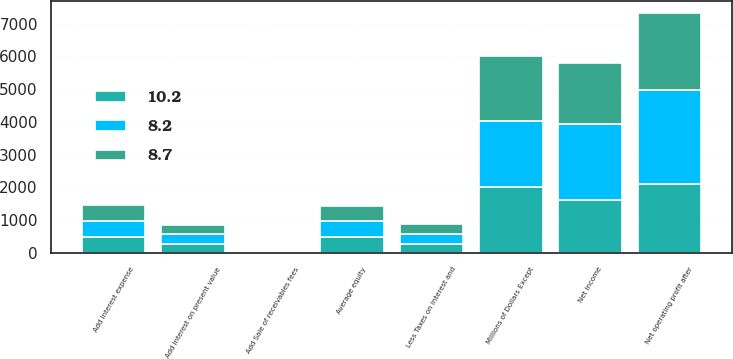Convert chart. <chart><loc_0><loc_0><loc_500><loc_500><stacked_bar_chart><ecel><fcel>Millions of Dollars Except<fcel>Net income<fcel>Add Interest expense<fcel>Add Sale of receivables fees<fcel>Add Interest on present value<fcel>Less Taxes on interest and<fcel>Net operating profit after<fcel>Average equity<nl><fcel>8.2<fcel>2008<fcel>2338<fcel>511<fcel>23<fcel>299<fcel>301<fcel>2870<fcel>482<nl><fcel>8.7<fcel>2007<fcel>1855<fcel>482<fcel>35<fcel>292<fcel>310<fcel>2354<fcel>482<nl><fcel>10.2<fcel>2006<fcel>1606<fcel>477<fcel>33<fcel>268<fcel>283<fcel>2101<fcel>482<nl></chart> 